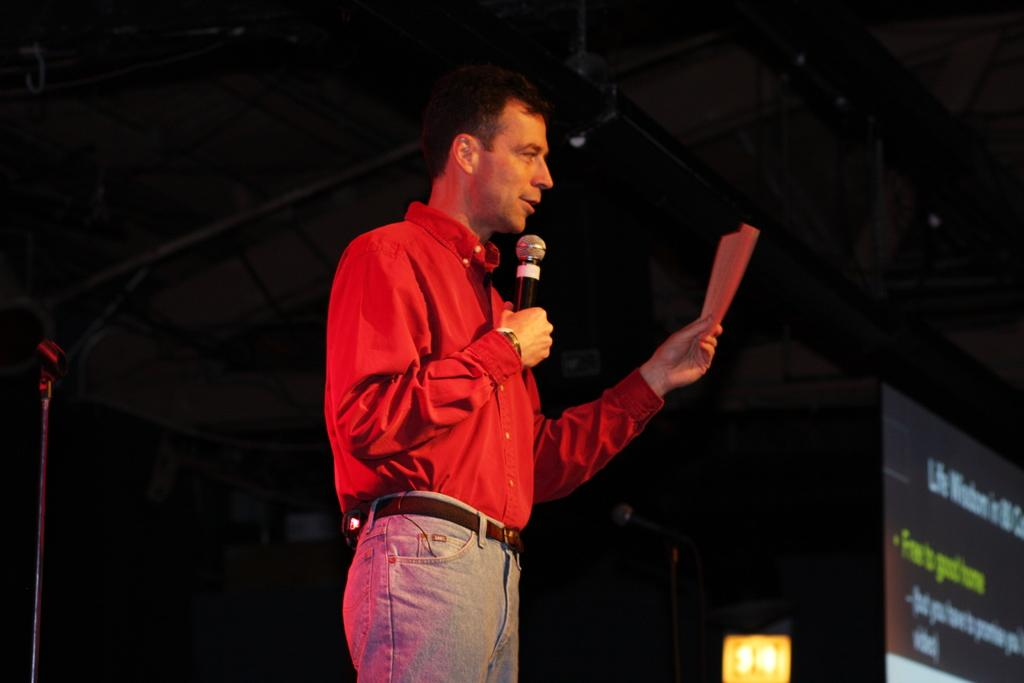What is the man in the image wearing? The man is wearing a red shirt and grey jeans. What is the man doing in the image? The man is talking on a mic and holding a paper. What can be seen on the right side of the image? There is a screen on the right side of the image. How would you describe the lighting in the image? The background of the image is dark. What decision is the man making while driving in the image? There is no driving or decision-making activity depicted in the image; the man is talking on a mic and holding a paper. 